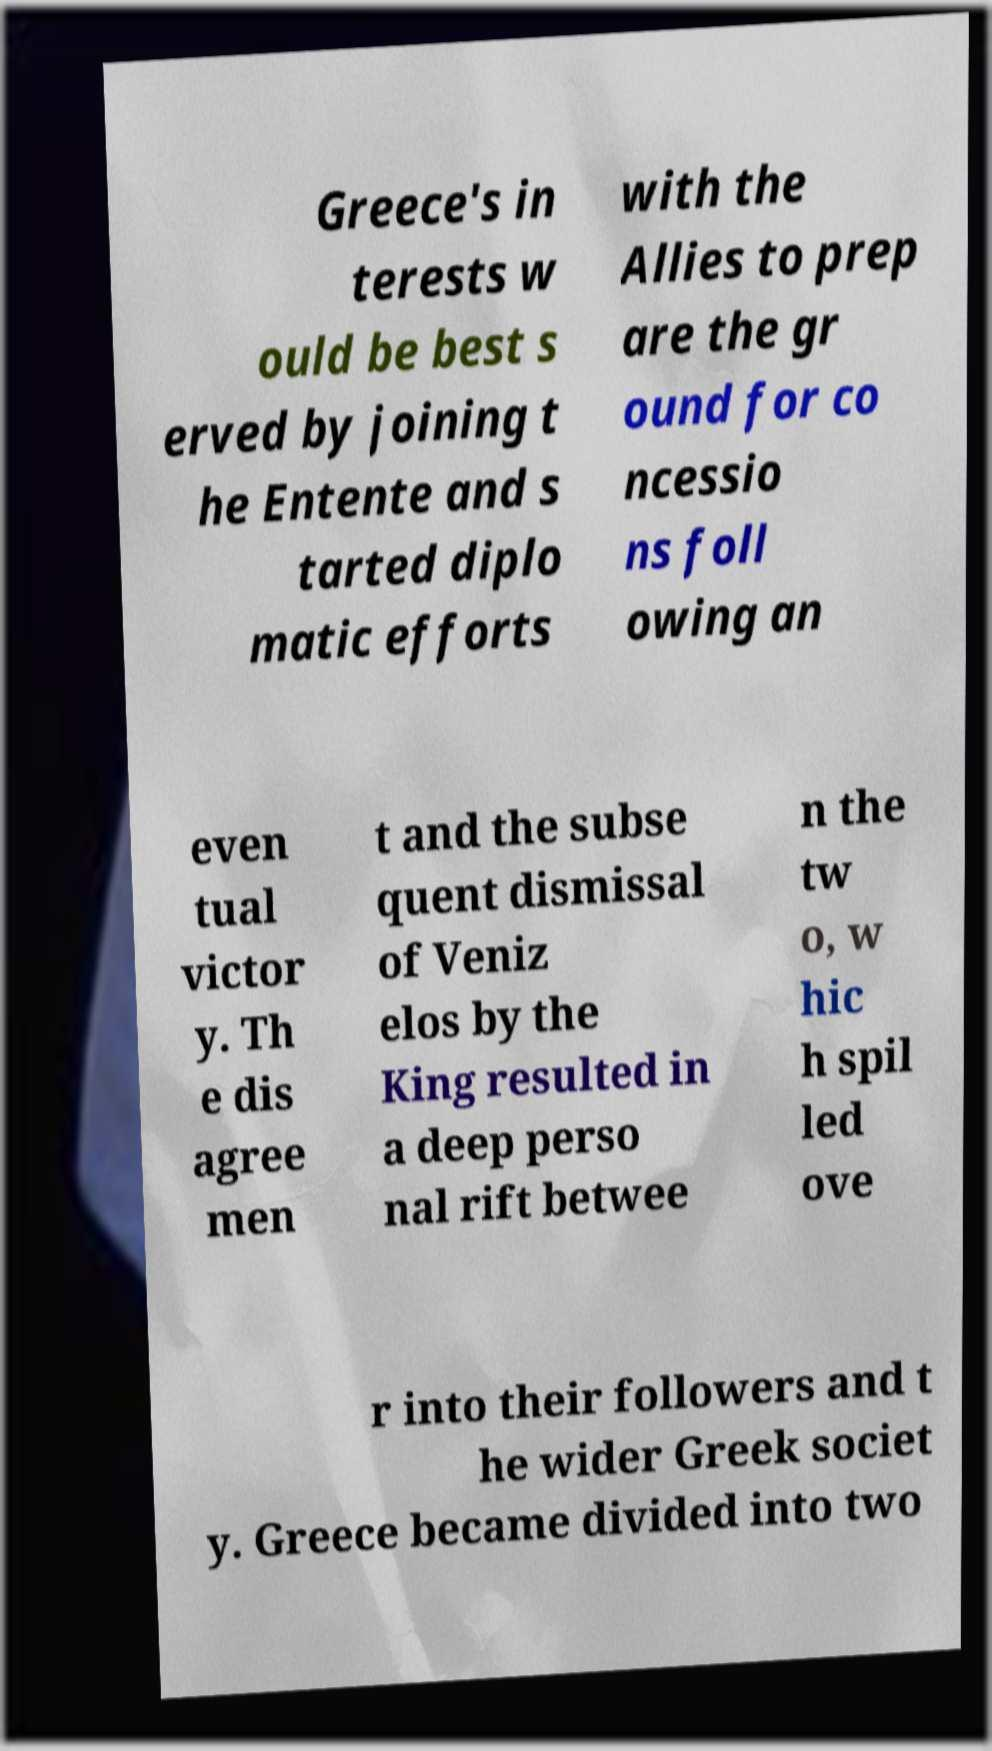Can you accurately transcribe the text from the provided image for me? Greece's in terests w ould be best s erved by joining t he Entente and s tarted diplo matic efforts with the Allies to prep are the gr ound for co ncessio ns foll owing an even tual victor y. Th e dis agree men t and the subse quent dismissal of Veniz elos by the King resulted in a deep perso nal rift betwee n the tw o, w hic h spil led ove r into their followers and t he wider Greek societ y. Greece became divided into two 